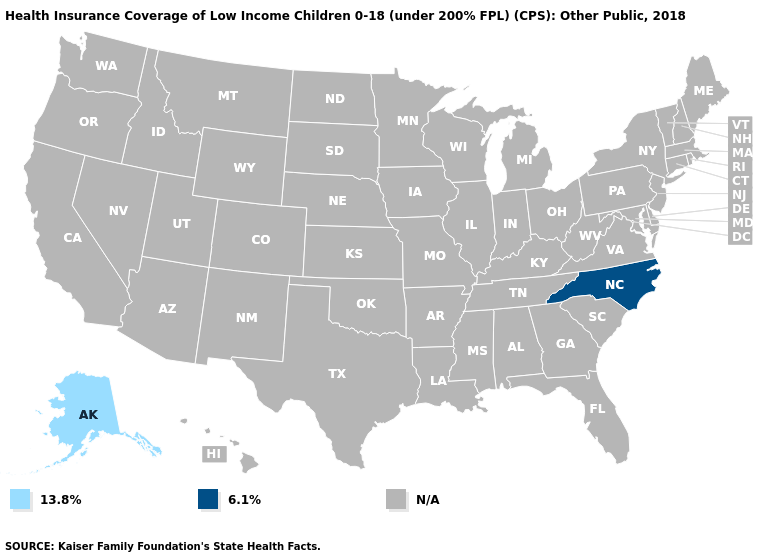Name the states that have a value in the range N/A?
Answer briefly. Alabama, Arizona, Arkansas, California, Colorado, Connecticut, Delaware, Florida, Georgia, Hawaii, Idaho, Illinois, Indiana, Iowa, Kansas, Kentucky, Louisiana, Maine, Maryland, Massachusetts, Michigan, Minnesota, Mississippi, Missouri, Montana, Nebraska, Nevada, New Hampshire, New Jersey, New Mexico, New York, North Dakota, Ohio, Oklahoma, Oregon, Pennsylvania, Rhode Island, South Carolina, South Dakota, Tennessee, Texas, Utah, Vermont, Virginia, Washington, West Virginia, Wisconsin, Wyoming. Name the states that have a value in the range 13.8%?
Give a very brief answer. Alaska. What is the value of Arkansas?
Answer briefly. N/A. Name the states that have a value in the range 6.1%?
Short answer required. North Carolina. What is the value of Rhode Island?
Be succinct. N/A. Name the states that have a value in the range 6.1%?
Quick response, please. North Carolina. Name the states that have a value in the range N/A?
Concise answer only. Alabama, Arizona, Arkansas, California, Colorado, Connecticut, Delaware, Florida, Georgia, Hawaii, Idaho, Illinois, Indiana, Iowa, Kansas, Kentucky, Louisiana, Maine, Maryland, Massachusetts, Michigan, Minnesota, Mississippi, Missouri, Montana, Nebraska, Nevada, New Hampshire, New Jersey, New Mexico, New York, North Dakota, Ohio, Oklahoma, Oregon, Pennsylvania, Rhode Island, South Carolina, South Dakota, Tennessee, Texas, Utah, Vermont, Virginia, Washington, West Virginia, Wisconsin, Wyoming. What is the highest value in the USA?
Give a very brief answer. 6.1%. What is the value of Oregon?
Concise answer only. N/A. Which states hav the highest value in the South?
Be succinct. North Carolina. What is the lowest value in the USA?
Give a very brief answer. 13.8%. What is the value of Alabama?
Write a very short answer. N/A. 